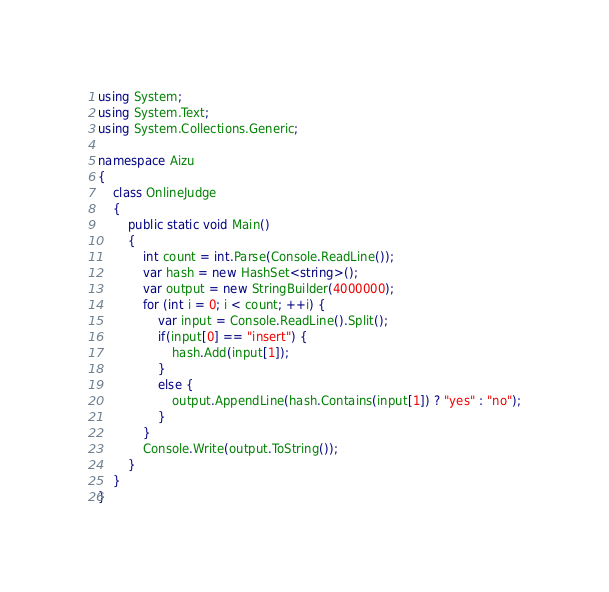<code> <loc_0><loc_0><loc_500><loc_500><_C#_>using System;
using System.Text;
using System.Collections.Generic;

namespace Aizu
{
    class OnlineJudge
    {
        public static void Main()
        {
            int count = int.Parse(Console.ReadLine());
            var hash = new HashSet<string>();
            var output = new StringBuilder(4000000);
            for (int i = 0; i < count; ++i) {
                var input = Console.ReadLine().Split();
                if(input[0] == "insert") {
                    hash.Add(input[1]);
                }
                else {
                    output.AppendLine(hash.Contains(input[1]) ? "yes" : "no");
                }
            }
            Console.Write(output.ToString());
        }
    }
}</code> 